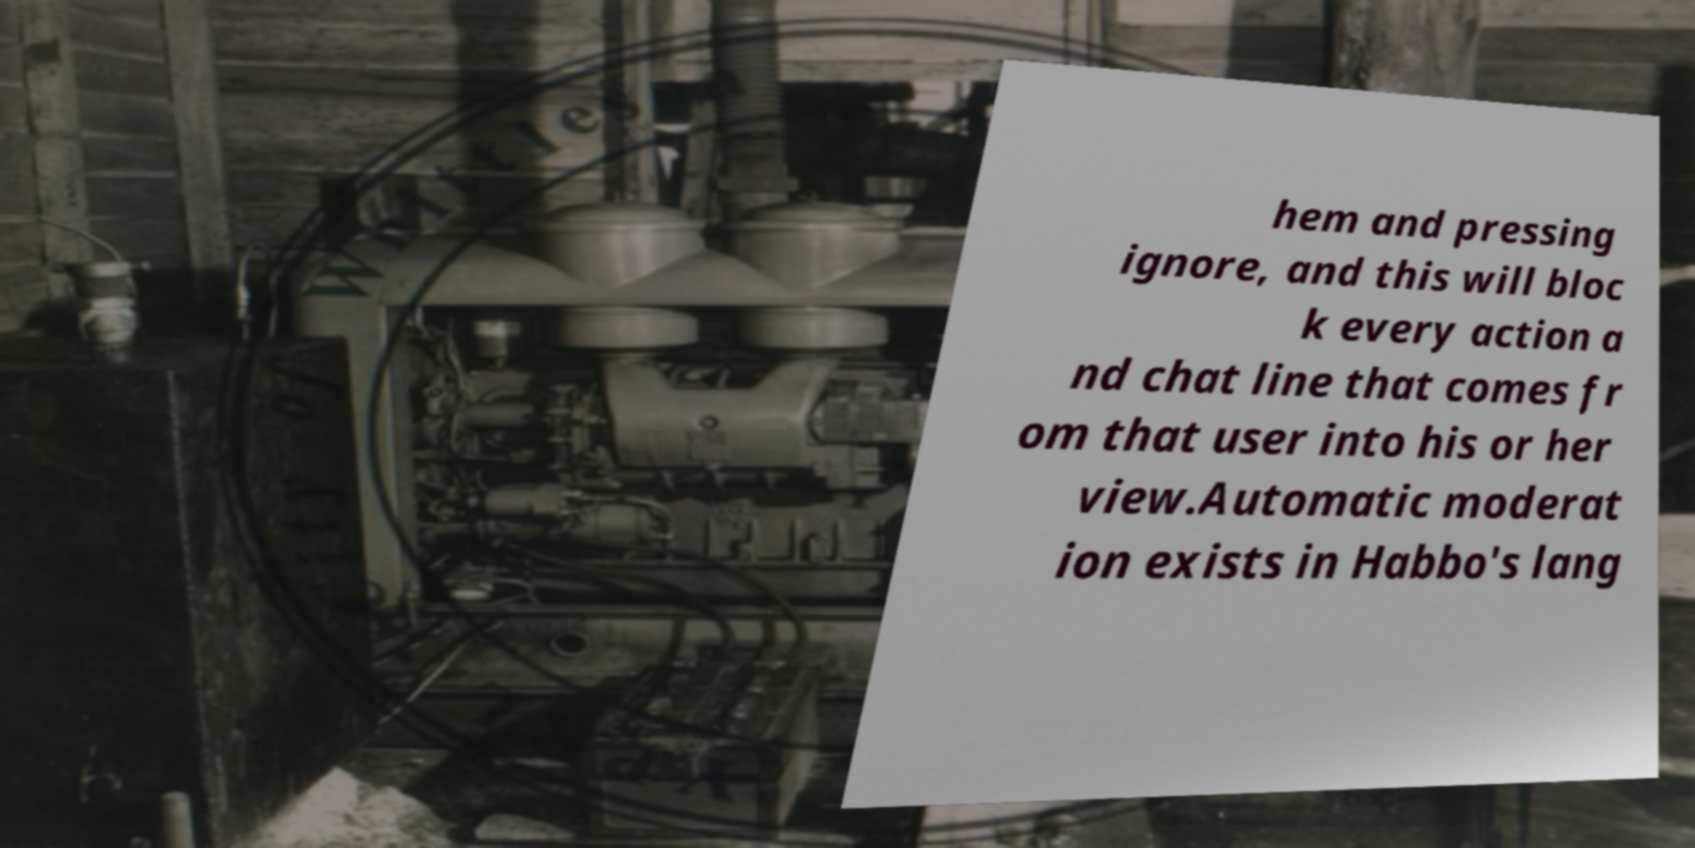Can you read and provide the text displayed in the image?This photo seems to have some interesting text. Can you extract and type it out for me? hem and pressing ignore, and this will bloc k every action a nd chat line that comes fr om that user into his or her view.Automatic moderat ion exists in Habbo's lang 